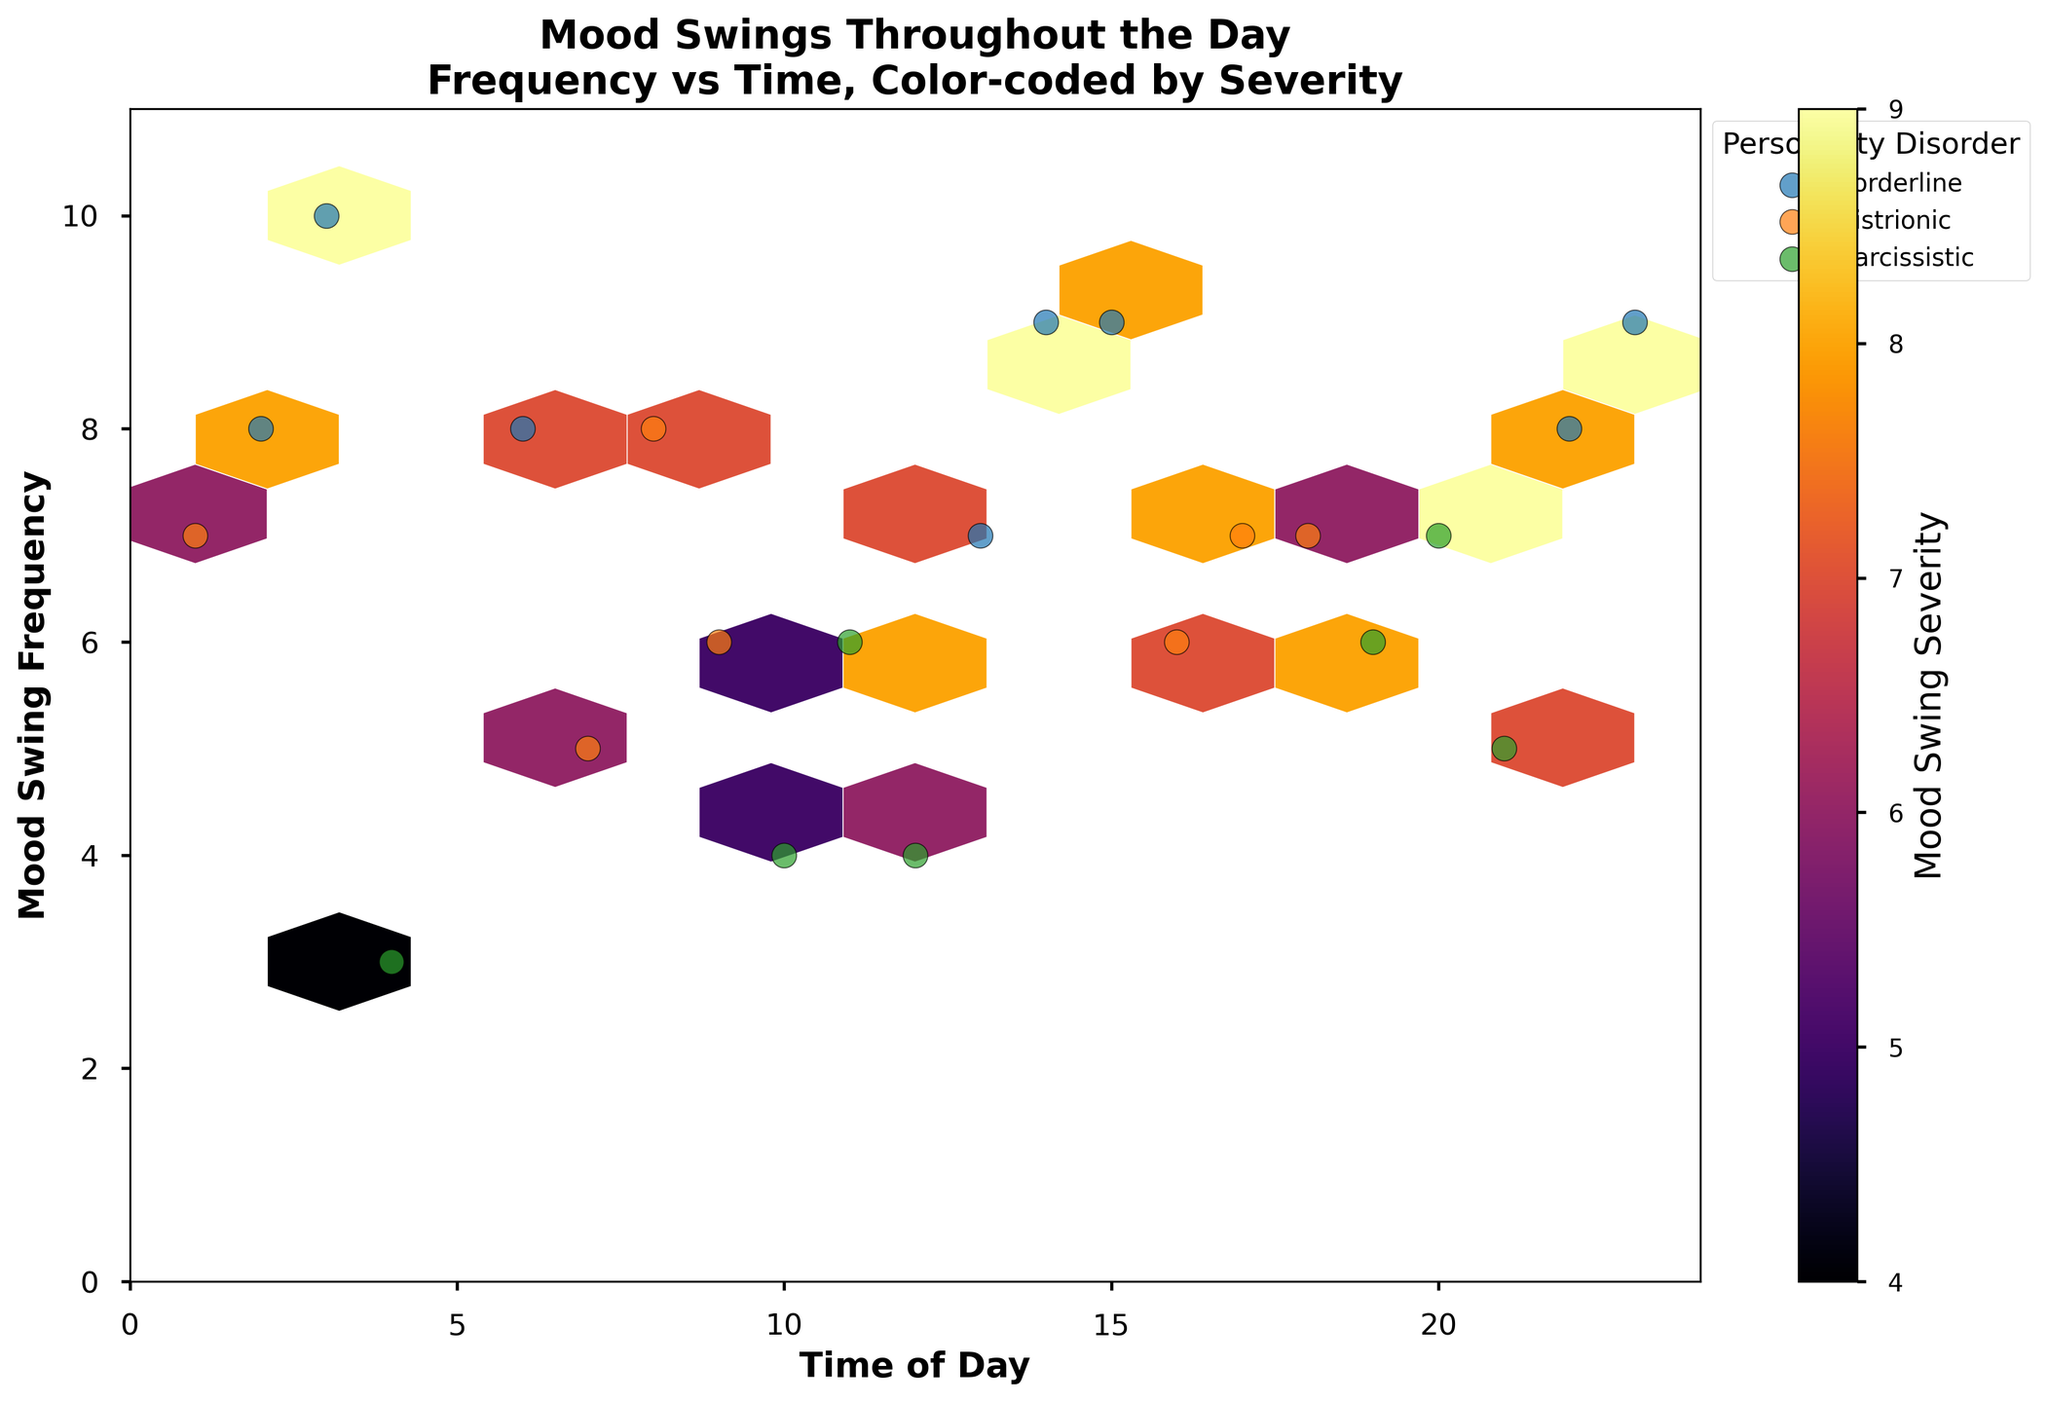Which time of day shows the highest frequency of mood swings? The highest frequency can be identified by finding the data point with the largest Mood Swing Frequency on the y-axis. The data shows the highest frequency value is 10, occurring at 3 AM.
Answer: 3 AM What is the color scale used to represent the severity of mood swings? The figure uses a color scale ranging from lighter to darker shades of the 'inferno' colormap to represent Mood Swing Severity, with lighter colors indicating lower severity and darker colors indicating higher severity.
Answer: 'Inferno' colormap How many personality disorders are represented in the plot? By looking at the legend, we can count the different labels representing personality disorders. The distinct categories are Borderline, Histrionic, and Narcissistic.
Answer: 3 During which time of day and due to which external stressor do individuals with Borderline Personality Disorder experience severe mood swings frequently? To answer this, find the Borderline data points on the plot with high severity and frequency. The points at 3 AM (Insomnia) and 14 PM (Financial Stress) are the most severe and frequent.
Answer: 3 AM, Insomnia and 14 PM, Financial Stress Compare the mood swing severity between individuals with Histrionic and Narcissistic Personality Disorders at similar mood swing frequencies. Compare the severities of similar frequencies (y-axis values) and check corresponding colors. For example, at frequencies of 7, Histrionic shows colors corresponding to severities around 6-8, while Narcissistic shows around 9, indicating higher severity.
Answer: Narcissistic > Histrionic What is the general trend of mood swing frequency throughout the day for all personality disorders combined? By observing the spread of data points on the x and y axes, it appears that higher frequencies of mood swings tend to occur in the early morning (around 2-3 AM) and late night (22-23 PM) compared to mid-afternoon.
Answer: Early morning and late night have higher frequencies Which external stressor associated with Narcissistic Personality Disorder appears the least severe in terms of mood swings? Look at the lightest color points among Narcissistic Personality Disorder. The dot at 4 AM experiencing Morning Rush represents the lowest severity (around 4).
Answer: Morning Rush What is the distribution range of mood swing frequencies for Histrionic Personality Disorder? Look at the range of y-axis values for the Histrionic personality disorder data points. They span from a frequency of 5 to 8.
Answer: 5-8 Calculate the average mood swing severity for all data points labeled with Borderline Personality Disorder. To find the average, list the severity values for Borderline (7, 8, 9, 9, 9, 8, 9), sum them (59), and divide by the number of data points (7). 59/7 = 8.43
Answer: 8.43 Which time period has no recorded mood swings for individuals with Histrionic Personality Disorder? By examining the plot, there are no Histrionic points from 12 AM to 4 AM (early morning) and from 21 PM to 24 PM (late night).
Answer: 12 AM to 4 AM and 21 PM to 24 PM 